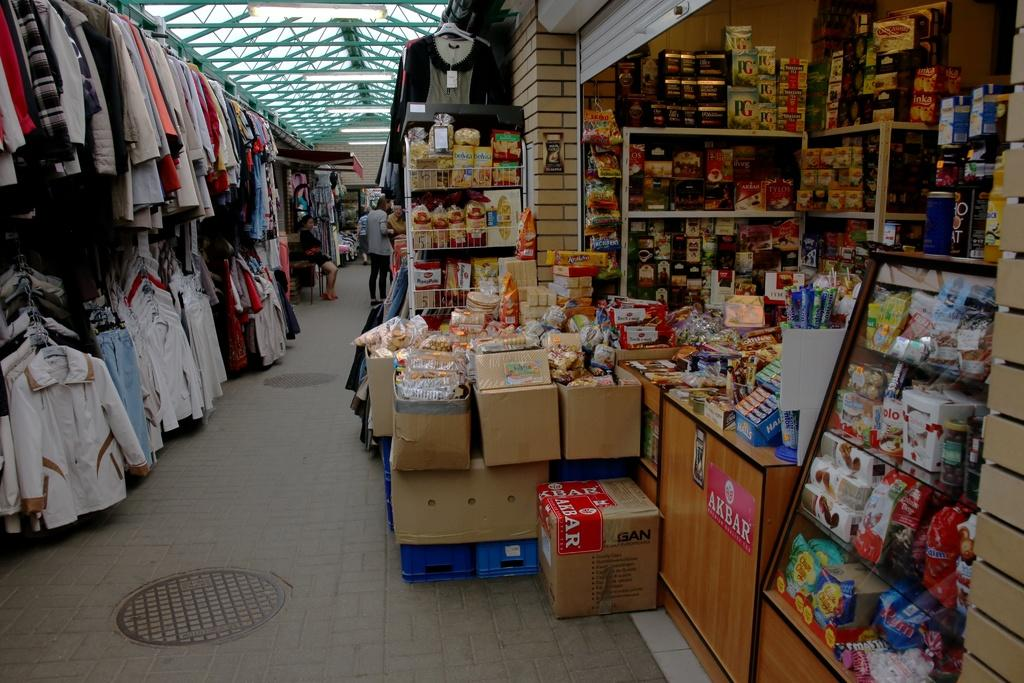<image>
Describe the image concisely. An Akbar sticker is on a box and below the counter of a store that sells clothing and other items. 